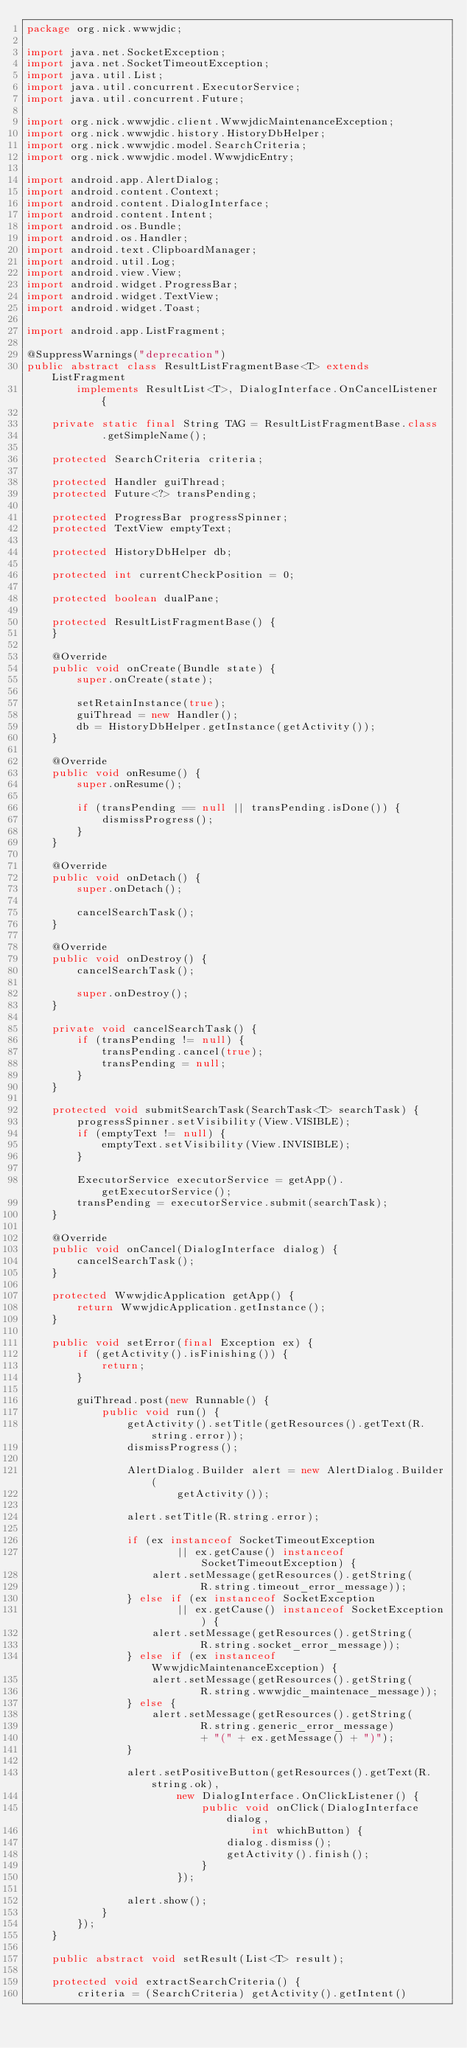<code> <loc_0><loc_0><loc_500><loc_500><_Java_>package org.nick.wwwjdic;

import java.net.SocketException;
import java.net.SocketTimeoutException;
import java.util.List;
import java.util.concurrent.ExecutorService;
import java.util.concurrent.Future;

import org.nick.wwwjdic.client.WwwjdicMaintenanceException;
import org.nick.wwwjdic.history.HistoryDbHelper;
import org.nick.wwwjdic.model.SearchCriteria;
import org.nick.wwwjdic.model.WwwjdicEntry;

import android.app.AlertDialog;
import android.content.Context;
import android.content.DialogInterface;
import android.content.Intent;
import android.os.Bundle;
import android.os.Handler;
import android.text.ClipboardManager;
import android.util.Log;
import android.view.View;
import android.widget.ProgressBar;
import android.widget.TextView;
import android.widget.Toast;

import android.app.ListFragment;

@SuppressWarnings("deprecation")
public abstract class ResultListFragmentBase<T> extends ListFragment
        implements ResultList<T>, DialogInterface.OnCancelListener {

    private static final String TAG = ResultListFragmentBase.class
            .getSimpleName();

    protected SearchCriteria criteria;

    protected Handler guiThread;
    protected Future<?> transPending;

    protected ProgressBar progressSpinner;
    protected TextView emptyText;

    protected HistoryDbHelper db;

    protected int currentCheckPosition = 0;

    protected boolean dualPane;

    protected ResultListFragmentBase() {
    }

    @Override
    public void onCreate(Bundle state) {
        super.onCreate(state);

        setRetainInstance(true);
        guiThread = new Handler();
        db = HistoryDbHelper.getInstance(getActivity());
    }

    @Override
    public void onResume() {
        super.onResume();

        if (transPending == null || transPending.isDone()) {
            dismissProgress();
        }
    }

    @Override
    public void onDetach() {
        super.onDetach();

        cancelSearchTask();
    }

    @Override
    public void onDestroy() {
        cancelSearchTask();

        super.onDestroy();
    }

    private void cancelSearchTask() {
        if (transPending != null) {
            transPending.cancel(true);
            transPending = null;
        }
    }

    protected void submitSearchTask(SearchTask<T> searchTask) {
        progressSpinner.setVisibility(View.VISIBLE);
        if (emptyText != null) {
            emptyText.setVisibility(View.INVISIBLE);
        }

        ExecutorService executorService = getApp().getExecutorService();
        transPending = executorService.submit(searchTask);
    }

    @Override
    public void onCancel(DialogInterface dialog) {
        cancelSearchTask();
    }

    protected WwwjdicApplication getApp() {
        return WwwjdicApplication.getInstance();
    }

    public void setError(final Exception ex) {
        if (getActivity().isFinishing()) {
            return;
        }

        guiThread.post(new Runnable() {
            public void run() {
                getActivity().setTitle(getResources().getText(R.string.error));
                dismissProgress();

                AlertDialog.Builder alert = new AlertDialog.Builder(
                        getActivity());

                alert.setTitle(R.string.error);

                if (ex instanceof SocketTimeoutException
                        || ex.getCause() instanceof SocketTimeoutException) {
                    alert.setMessage(getResources().getString(
                            R.string.timeout_error_message));
                } else if (ex instanceof SocketException
                        || ex.getCause() instanceof SocketException) {
                    alert.setMessage(getResources().getString(
                            R.string.socket_error_message));
                } else if (ex instanceof WwwjdicMaintenanceException) {
                    alert.setMessage(getResources().getString(
                            R.string.wwwjdic_maintenace_message));
                } else {
                    alert.setMessage(getResources().getString(
                            R.string.generic_error_message)
                            + "(" + ex.getMessage() + ")");
                }

                alert.setPositiveButton(getResources().getText(R.string.ok),
                        new DialogInterface.OnClickListener() {
                            public void onClick(DialogInterface dialog,
                                    int whichButton) {
                                dialog.dismiss();
                                getActivity().finish();
                            }
                        });

                alert.show();
            }
        });
    }

    public abstract void setResult(List<T> result);

    protected void extractSearchCriteria() {
        criteria = (SearchCriteria) getActivity().getIntent()</code> 